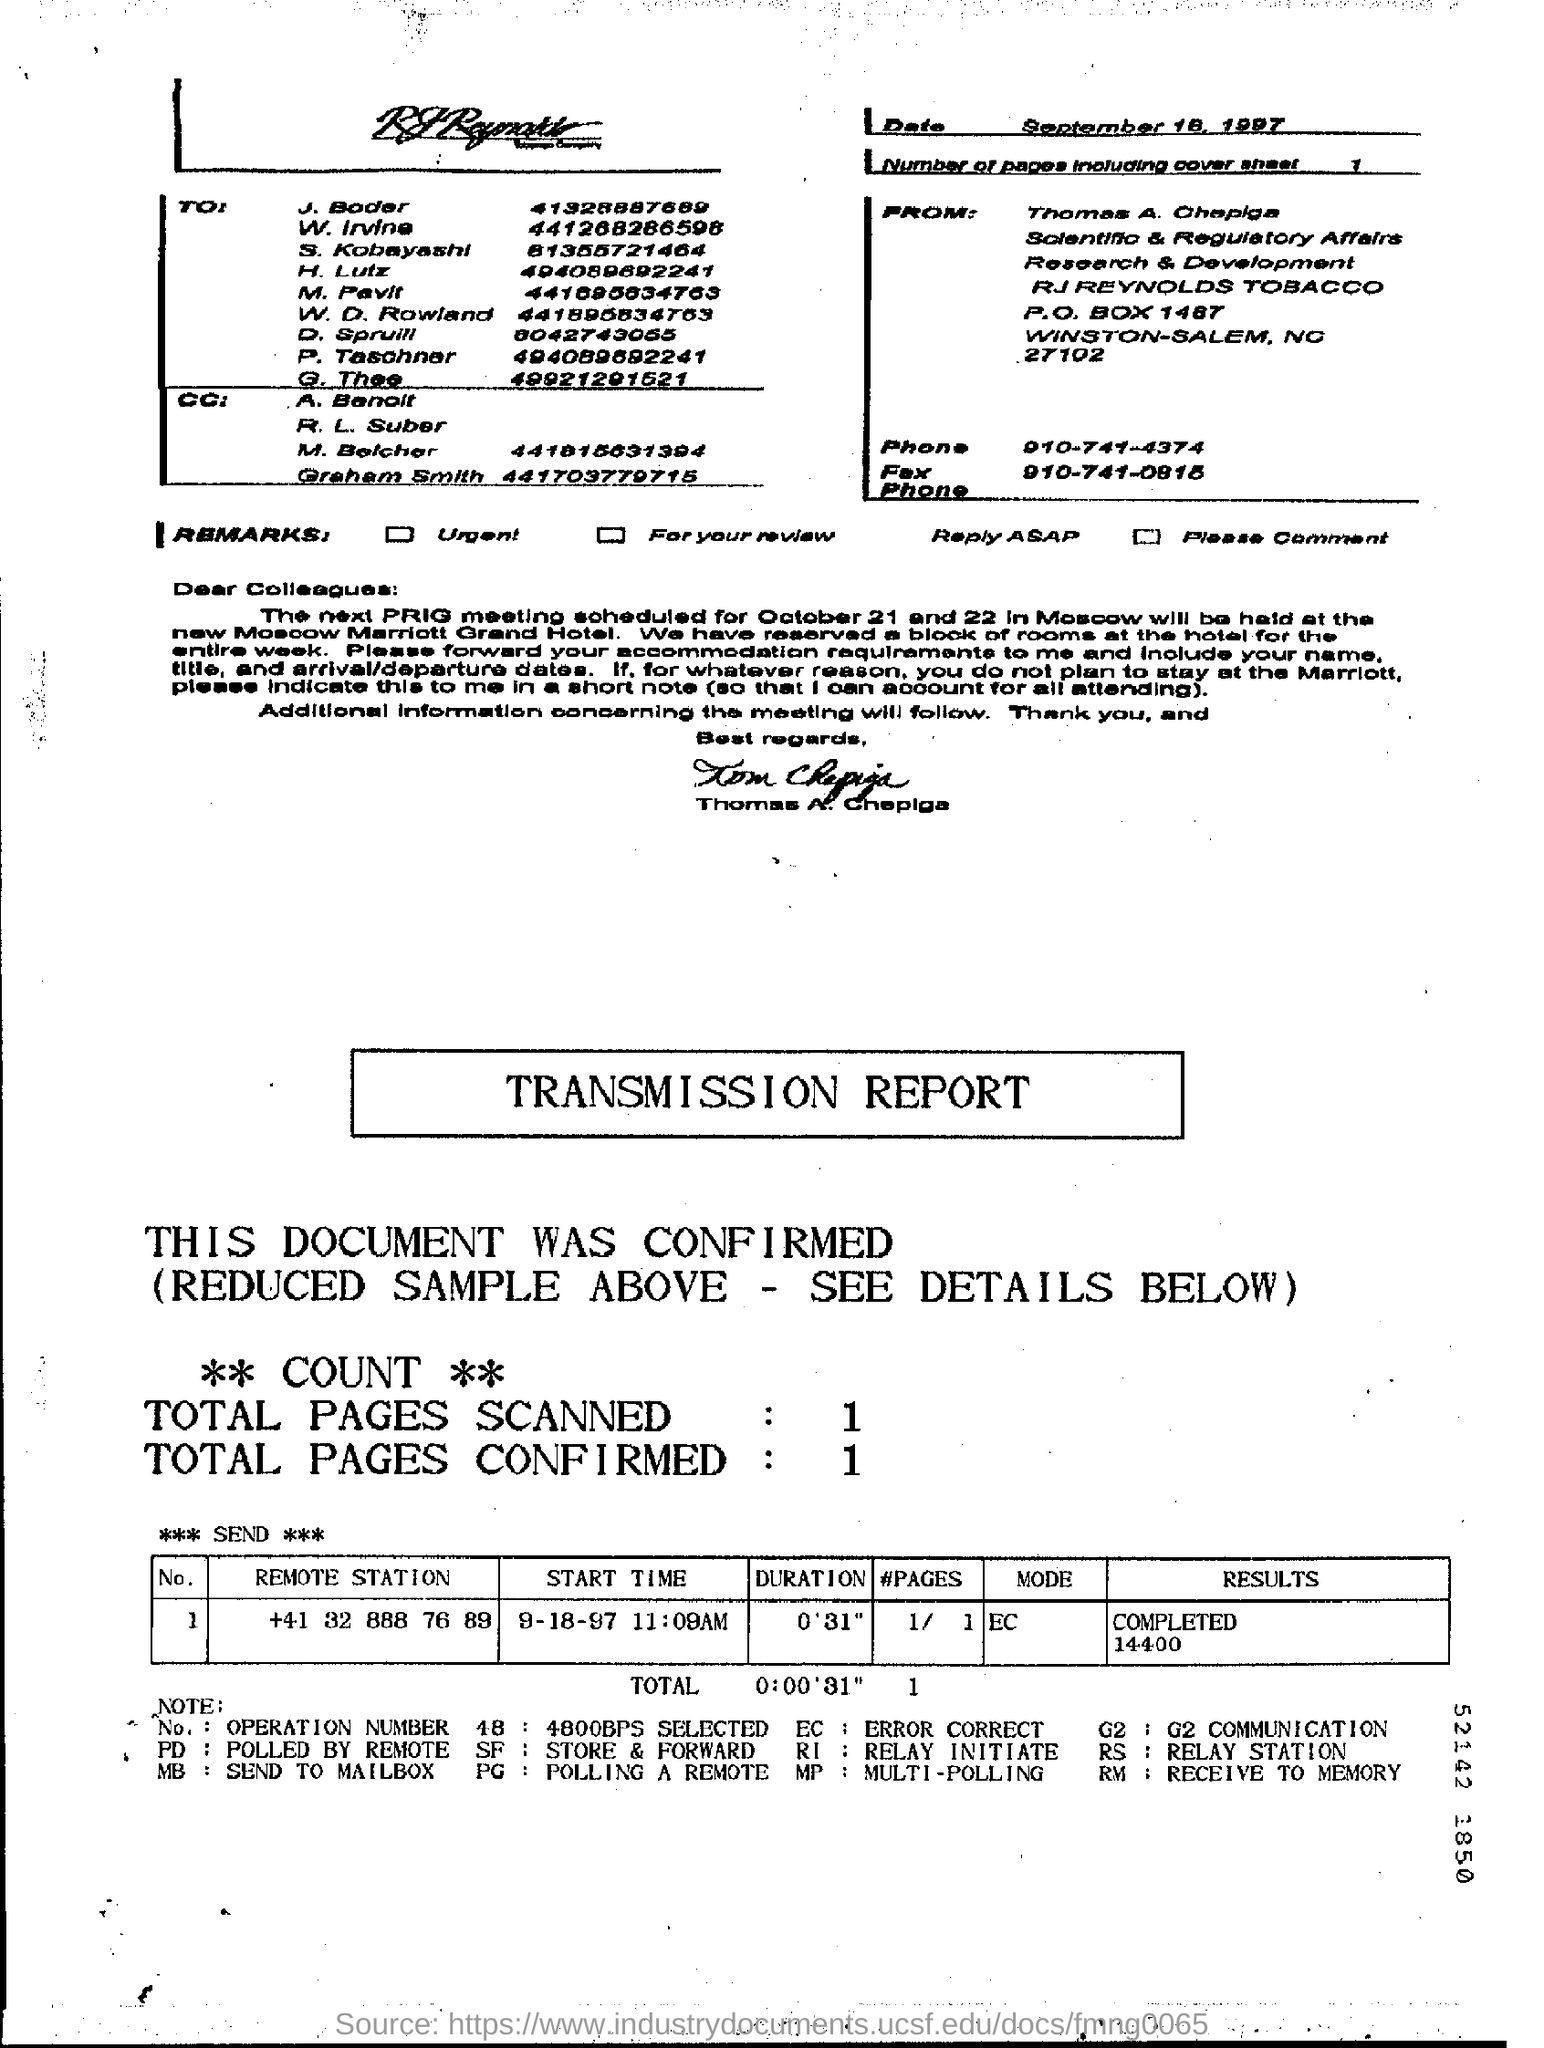Mention the date at top right corner of the page ?
Your response must be concise. September 18, 1997. How many total pages are scanned ?
Your answer should be very brief. 1. How many number of pages (including cover sheet) are there ?
Your response must be concise. 1. 